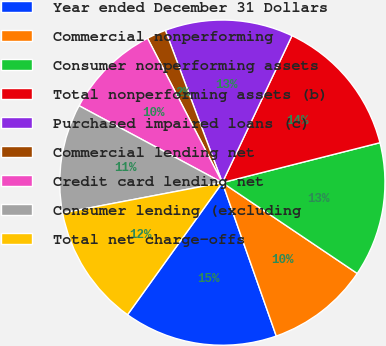Convert chart to OTSL. <chart><loc_0><loc_0><loc_500><loc_500><pie_chart><fcel>Year ended December 31 Dollars<fcel>Commercial nonperforming<fcel>Consumer nonperforming assets<fcel>Total nonperforming assets (b)<fcel>Purchased impaired loans (c)<fcel>Commercial lending net<fcel>Credit card lending net<fcel>Consumer lending (excluding<fcel>Total net charge-offs<nl><fcel>15.29%<fcel>10.19%<fcel>13.38%<fcel>14.01%<fcel>12.74%<fcel>1.91%<fcel>9.55%<fcel>10.83%<fcel>12.1%<nl></chart> 